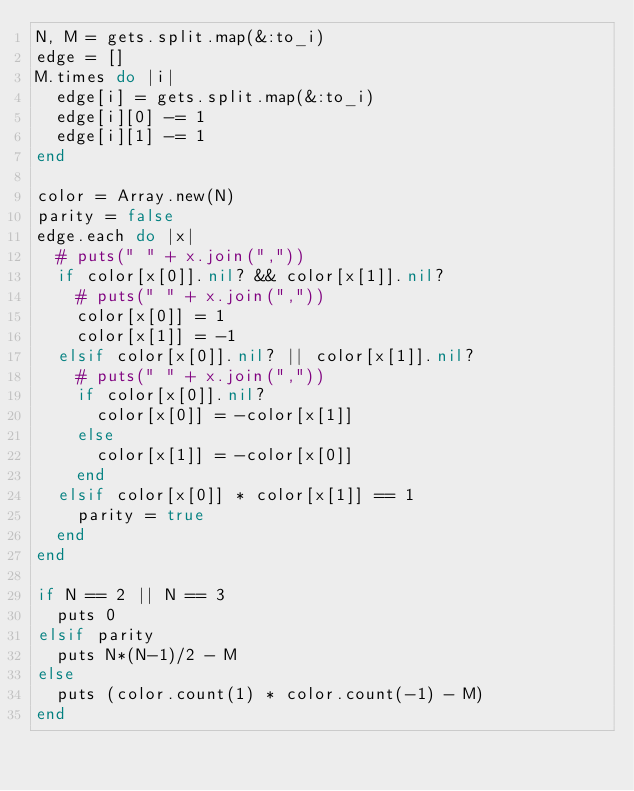Convert code to text. <code><loc_0><loc_0><loc_500><loc_500><_Ruby_>N, M = gets.split.map(&:to_i)
edge = []
M.times do |i|
  edge[i] = gets.split.map(&:to_i)
  edge[i][0] -= 1
  edge[i][1] -= 1
end

color = Array.new(N)
parity = false
edge.each do |x|
  # puts(" " + x.join(","))
  if color[x[0]].nil? && color[x[1]].nil?
    # puts(" " + x.join(","))
    color[x[0]] = 1
    color[x[1]] = -1
  elsif color[x[0]].nil? || color[x[1]].nil?
    # puts(" " + x.join(","))
    if color[x[0]].nil?
      color[x[0]] = -color[x[1]]
    else
      color[x[1]] = -color[x[0]]
    end
  elsif color[x[0]] * color[x[1]] == 1
    parity = true
  end
end

if N == 2 || N == 3
  puts 0
elsif parity
  puts N*(N-1)/2 - M
else
  puts (color.count(1) * color.count(-1) - M)
end
</code> 